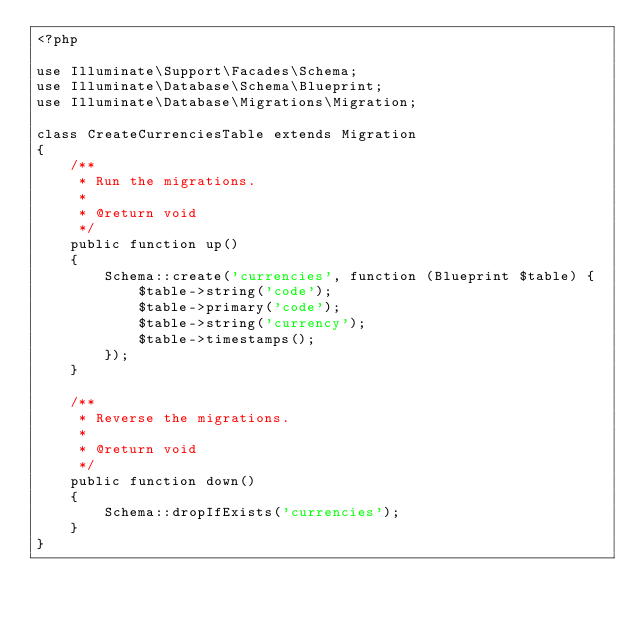Convert code to text. <code><loc_0><loc_0><loc_500><loc_500><_PHP_><?php

use Illuminate\Support\Facades\Schema;
use Illuminate\Database\Schema\Blueprint;
use Illuminate\Database\Migrations\Migration;

class CreateCurrenciesTable extends Migration
{
    /**
     * Run the migrations.
     *
     * @return void
     */
    public function up()
    {
        Schema::create('currencies', function (Blueprint $table) {
            $table->string('code');
            $table->primary('code');
            $table->string('currency');
            $table->timestamps();
        });
    }

    /**
     * Reverse the migrations.
     *
     * @return void
     */
    public function down()
    {
        Schema::dropIfExists('currencies');
    }
}
</code> 